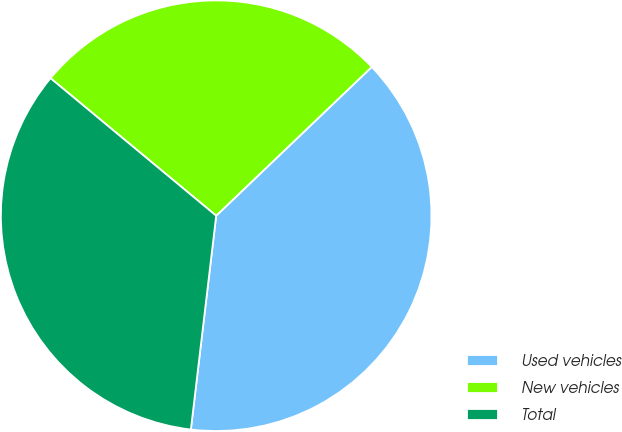Convert chart to OTSL. <chart><loc_0><loc_0><loc_500><loc_500><pie_chart><fcel>Used vehicles<fcel>New vehicles<fcel>Total<nl><fcel>39.02%<fcel>26.83%<fcel>34.15%<nl></chart> 